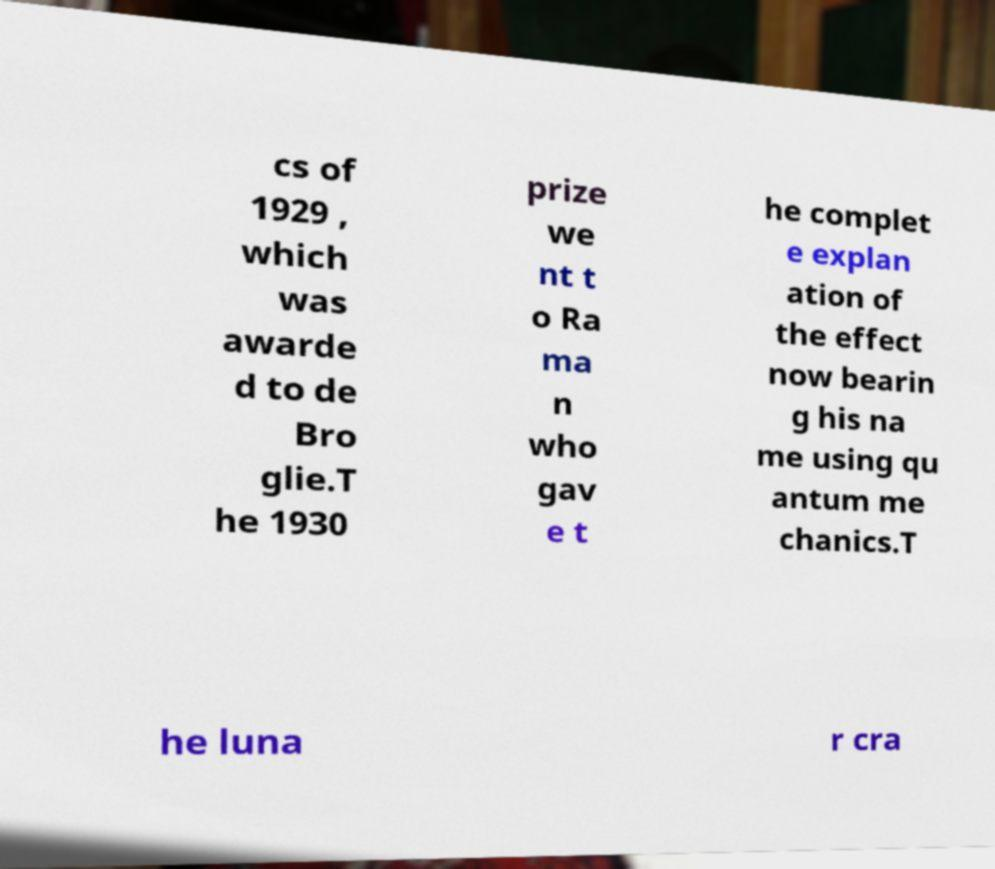For documentation purposes, I need the text within this image transcribed. Could you provide that? cs of 1929 , which was awarde d to de Bro glie.T he 1930 prize we nt t o Ra ma n who gav e t he complet e explan ation of the effect now bearin g his na me using qu antum me chanics.T he luna r cra 